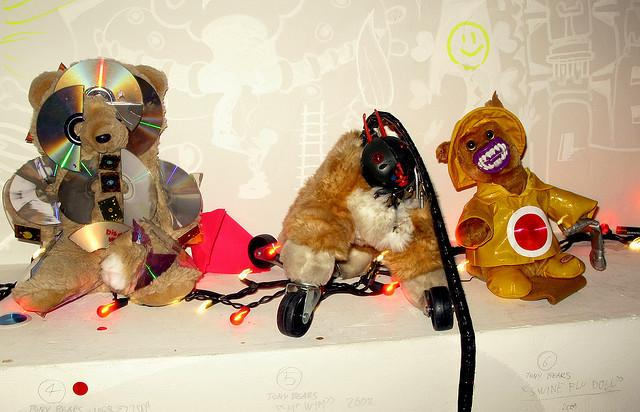What are the shattered items on the bear? Please explain your reasoning. cds. These flat platters are smaller than records. 